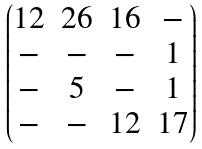<formula> <loc_0><loc_0><loc_500><loc_500>\begin{pmatrix} { 1 2 } & { 2 6 } & { 1 6 } & - \\ - & - & - & { 1 } \\ - & 5 & - & { 1 } \\ - & - & 1 2 & 1 7 \end{pmatrix}</formula> 